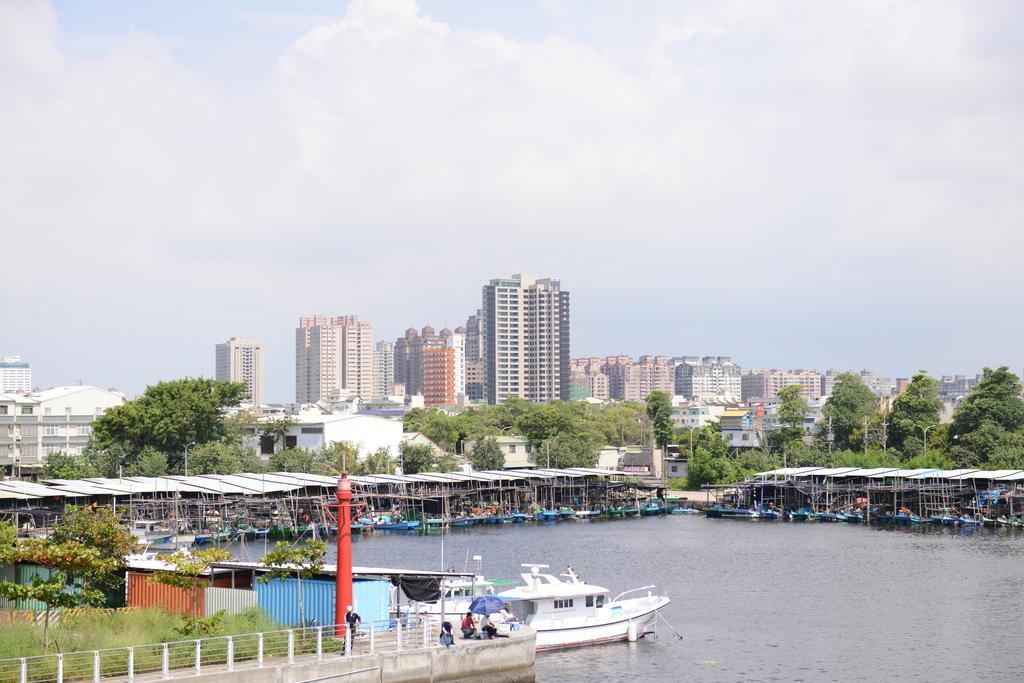Please provide a concise description of this image. In this image at the bottom there is a sea, and on the left side there are some plants, trees and some shelters, railing, pole and some people are sitting and one person is holding an umbrella and there is a ship. In the background there are some shelters, ships and some poles, trees, buildings, and at the top there is sky. 